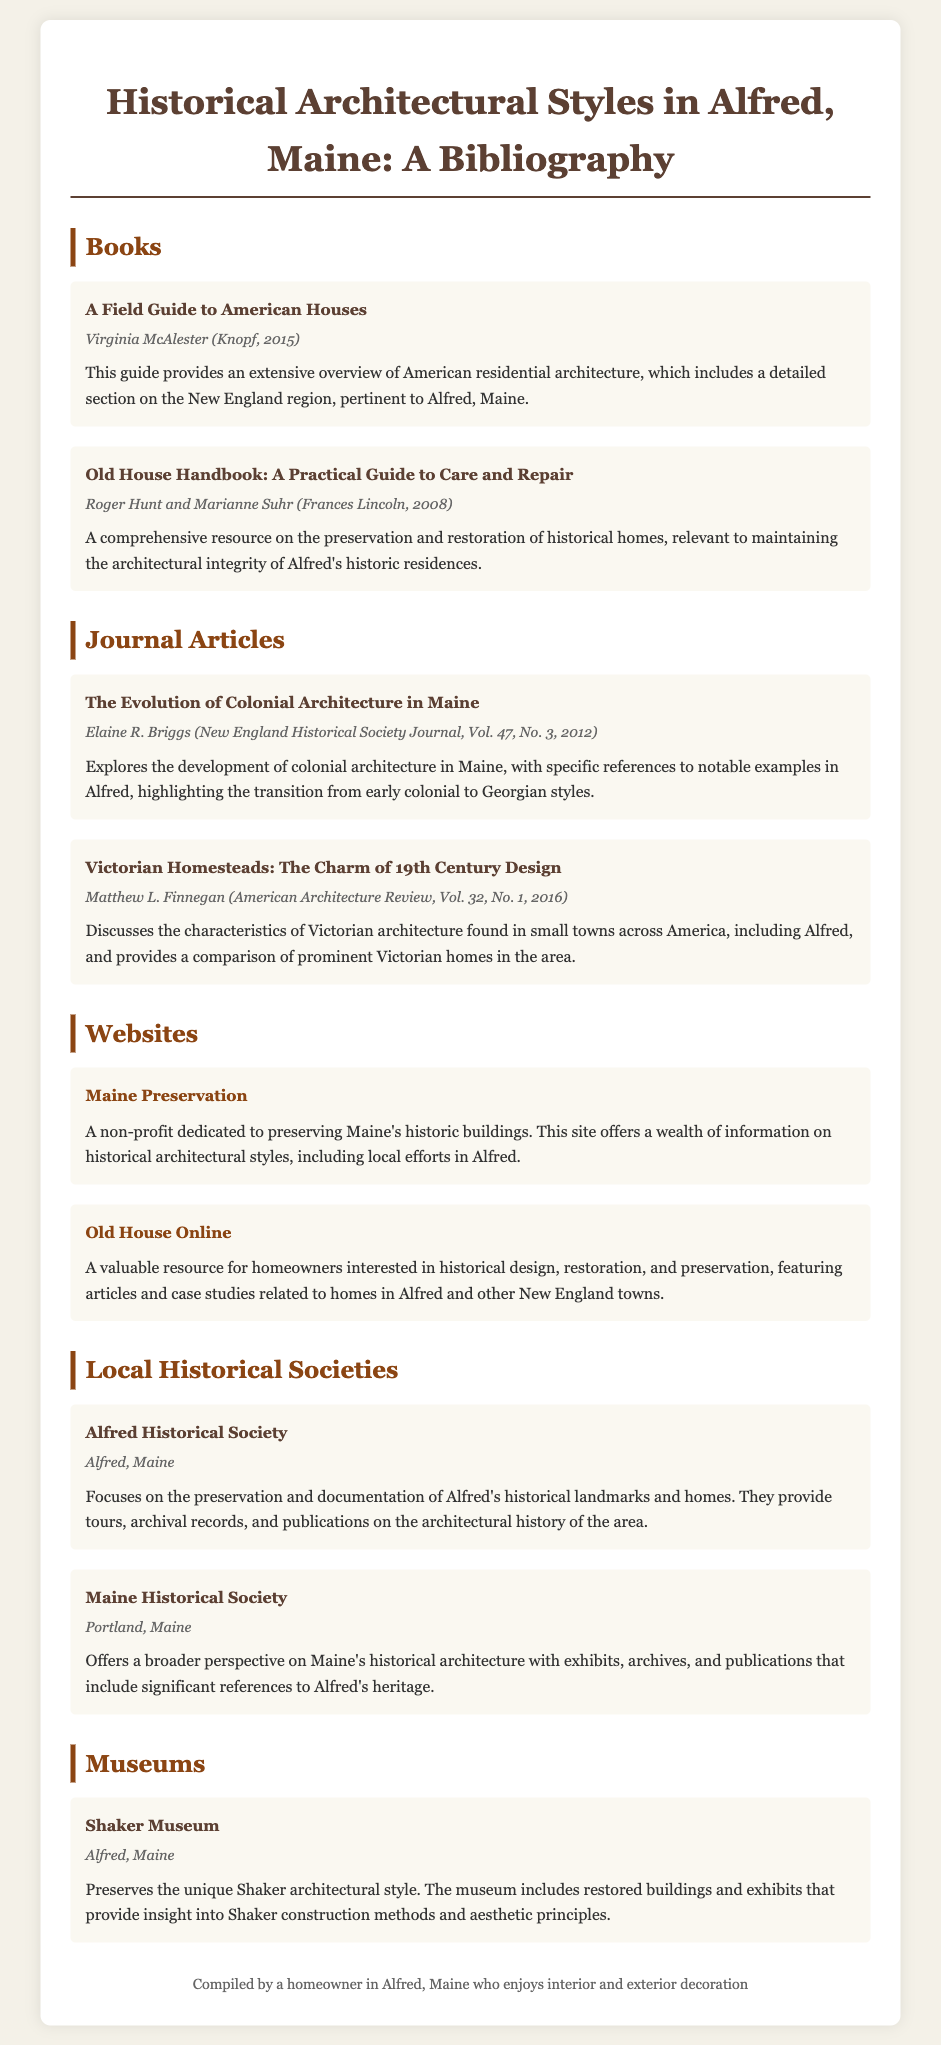what is the title of the bibliography? The title of the bibliography is stated prominently at the top of the document.
Answer: Historical Architectural Styles in Alfred, Maine: A Bibliography who authored "A Field Guide to American Houses"? The author of the book is noted in the bibliographical entry.
Answer: Virginia McAlester which historical society is located in Alfred, Maine? The document lists local historical societies along with their locations.
Answer: Alfred Historical Society what year was "Old House Handbook: A Practical Guide to Care and Repair" published? The publication year is included in the details of the bibliographic entry for the book.
Answer: 2008 what is the focus of the "Shaker Museum"? The description provides insight into what the museum preserves and showcases.
Answer: Shaker architectural style which journal discusses the evolution of Colonial architecture specifically in Maine? The title of the journal article specifically addresses Colonial architecture in Maine.
Answer: The Evolution of Colonial Architecture in Maine how many journal articles are listed in the bibliography? The document contains a specific section for journal articles, and the number can be counted.
Answer: 2 what is the name of the resource dedicated to preserving Maine's historic buildings? The title of the website indicates its purpose regarding preservation in Maine.
Answer: Maine Preservation which city is home to the Maine Historical Society? The location of the Maine Historical Society is mentioned in the bibliographic entry.
Answer: Portland, Maine 